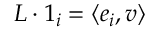Convert formula to latex. <formula><loc_0><loc_0><loc_500><loc_500>L \cdot 1 _ { i } = \langle e _ { i } , v \rangle</formula> 